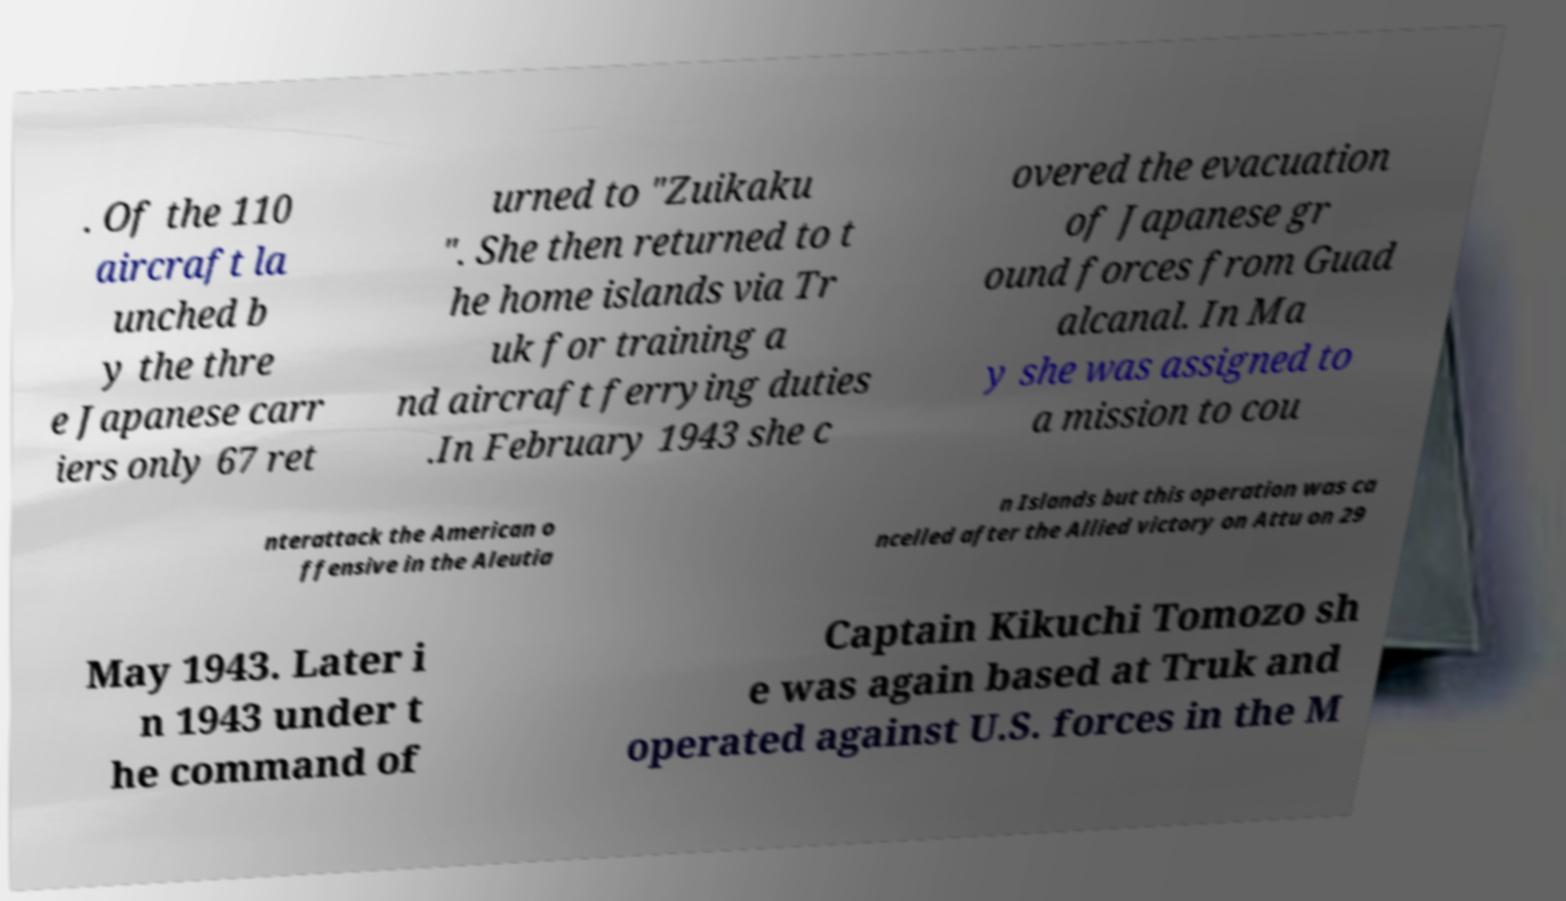What messages or text are displayed in this image? I need them in a readable, typed format. . Of the 110 aircraft la unched b y the thre e Japanese carr iers only 67 ret urned to "Zuikaku ". She then returned to t he home islands via Tr uk for training a nd aircraft ferrying duties .In February 1943 she c overed the evacuation of Japanese gr ound forces from Guad alcanal. In Ma y she was assigned to a mission to cou nterattack the American o ffensive in the Aleutia n Islands but this operation was ca ncelled after the Allied victory on Attu on 29 May 1943. Later i n 1943 under t he command of Captain Kikuchi Tomozo sh e was again based at Truk and operated against U.S. forces in the M 